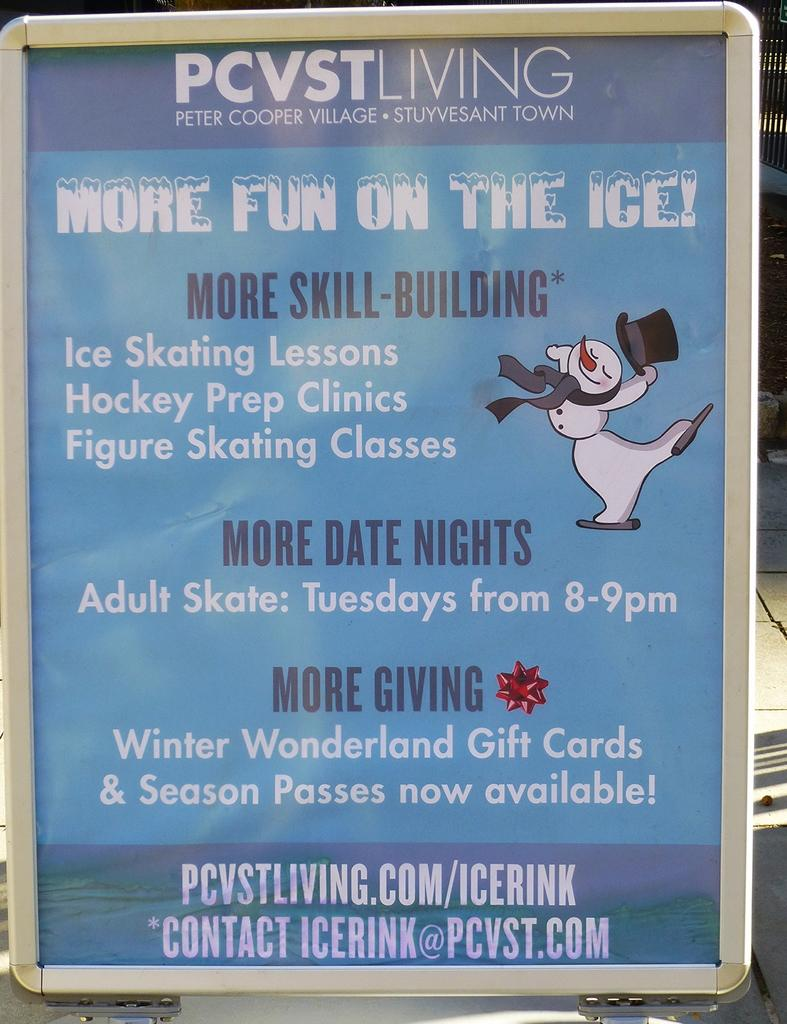Provide a one-sentence caption for the provided image. Peter Cooper Village has a sign offering ice skating lessons. 